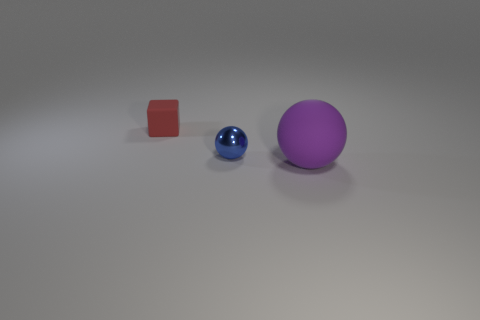What number of things are both on the left side of the big sphere and on the right side of the tiny ball?
Make the answer very short. 0. There is a rubber object that is in front of the blue metal thing; is it the same color as the object that is behind the metallic ball?
Offer a very short reply. No. Is there any other thing that has the same material as the purple sphere?
Offer a very short reply. Yes. The other object that is the same shape as the blue object is what size?
Your answer should be compact. Large. Are there any red matte objects in front of the blue ball?
Offer a very short reply. No. Are there the same number of tiny spheres that are on the right side of the big rubber thing and small blue metallic things?
Your answer should be compact. No. Is there a big sphere that is behind the sphere left of the matte thing in front of the cube?
Offer a very short reply. No. What is the material of the tiny ball?
Make the answer very short. Metal. How many other things are the same shape as the large purple thing?
Give a very brief answer. 1. Is the red matte thing the same shape as the blue metal thing?
Your response must be concise. No. 